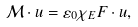Convert formula to latex. <formula><loc_0><loc_0><loc_500><loc_500>\mathcal { M } \cdot u = \varepsilon _ { 0 } \chi _ { E } F \cdot u ,</formula> 